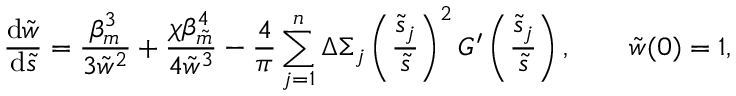Convert formula to latex. <formula><loc_0><loc_0><loc_500><loc_500>\frac { d \tilde { w } } { d \tilde { s } } = \frac { \beta _ { m } ^ { 3 } } { 3 \tilde { w } ^ { 2 } } + \frac { \chi \beta _ { \tilde { m } } ^ { 4 } } { 4 \tilde { w } ^ { 3 } } - \frac { 4 } { \pi } \sum _ { j = 1 } ^ { n } \Delta \Sigma _ { j } \left ( \frac { \tilde { s } _ { j } } { \tilde { s } } \right ) ^ { 2 } G ^ { \prime } \left ( \frac { \tilde { s } _ { j } } { \tilde { s } } \right ) , \quad \tilde { w } ( 0 ) = 1 ,</formula> 